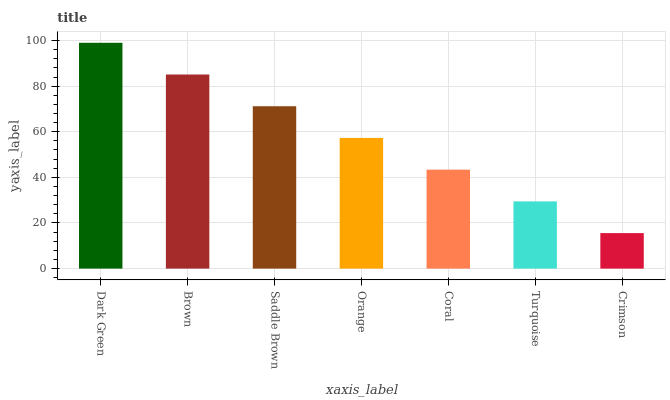Is Crimson the minimum?
Answer yes or no. Yes. Is Dark Green the maximum?
Answer yes or no. Yes. Is Brown the minimum?
Answer yes or no. No. Is Brown the maximum?
Answer yes or no. No. Is Dark Green greater than Brown?
Answer yes or no. Yes. Is Brown less than Dark Green?
Answer yes or no. Yes. Is Brown greater than Dark Green?
Answer yes or no. No. Is Dark Green less than Brown?
Answer yes or no. No. Is Orange the high median?
Answer yes or no. Yes. Is Orange the low median?
Answer yes or no. Yes. Is Brown the high median?
Answer yes or no. No. Is Saddle Brown the low median?
Answer yes or no. No. 